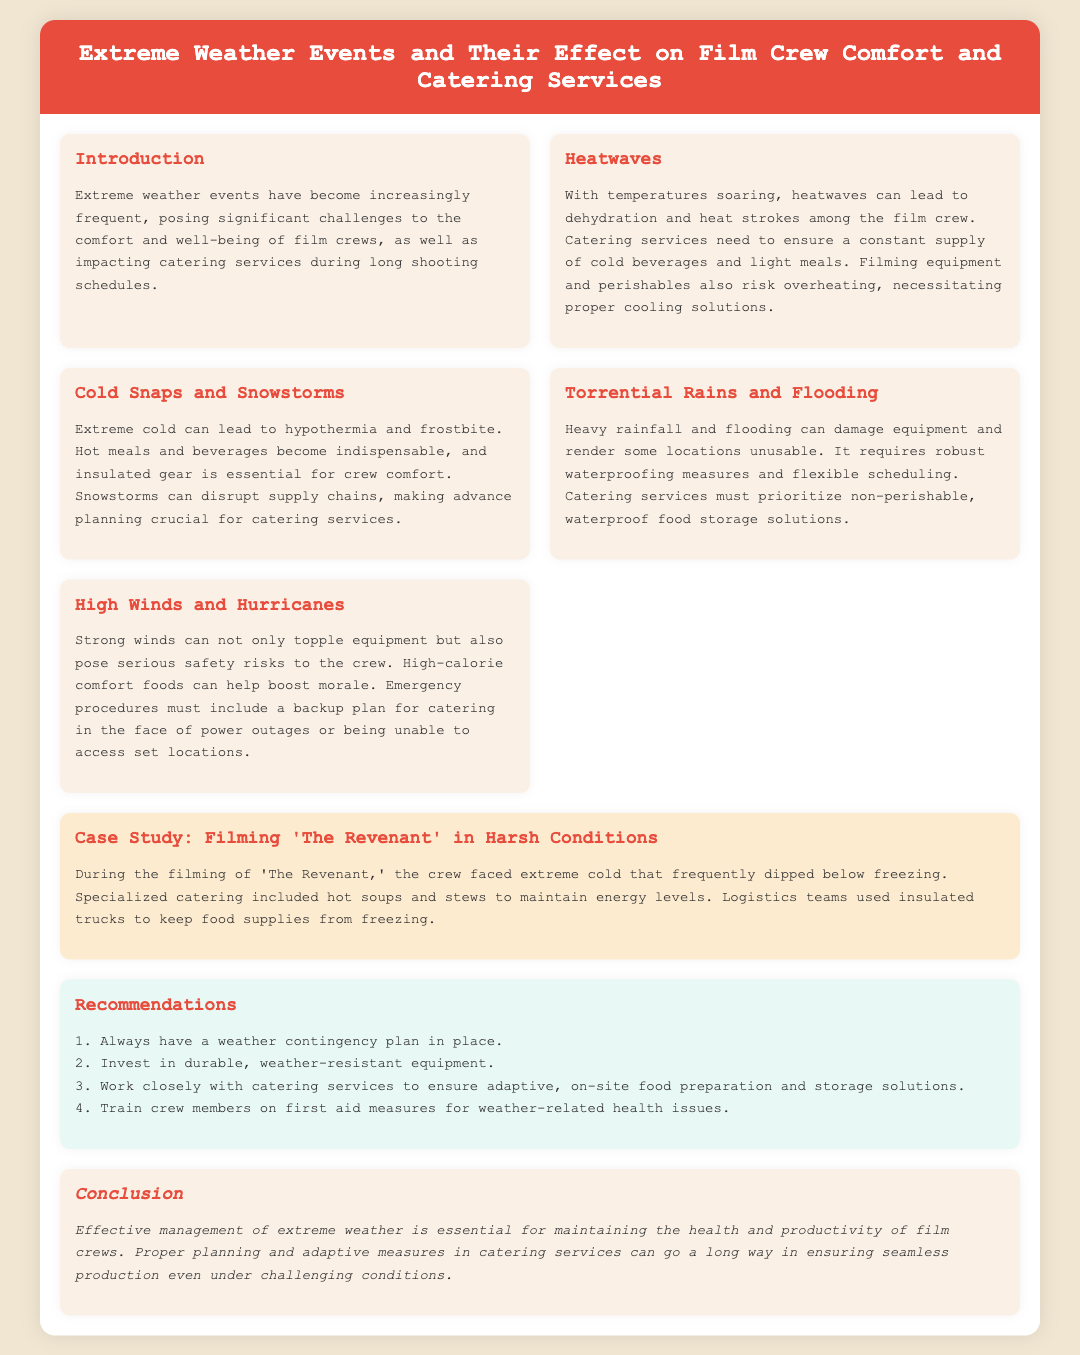What is the title of the document? The title of the document is presented in the header section, which is "Extreme Weather Events and Their Effect on Film Crew Comfort and Catering Services."
Answer: Extreme Weather Events and Their Effect on Film Crew Comfort and Catering Services What are the challenges posed by heatwaves? The challenges posed by heatwaves include dehydration and heat strokes among the film crew.
Answer: Dehydration and heat strokes What is crucial for catering during cold snaps and snowstorms? Catering during cold snaps and snowstorms must ensure a supply of hot meals and beverages.
Answer: Hot meals and beverages What is a key recommendation for handling extreme weather? A key recommendation is to always have a weather contingency plan in place.
Answer: Weather contingency plan What type of food is suggested during high winds? High-calorie comfort foods are suggested to help boost crew morale during high winds.
Answer: High-calorie comfort foods What was the filming condition experienced in 'The Revenant'? During the filming of 'The Revenant,' the crew faced extreme cold that frequently dipped below freezing.
Answer: Extreme cold What is the impact of torrential rains on catering services? Torrential rains require catering services to prioritize non-perishable, waterproof food storage solutions.
Answer: Non-perishable, waterproof food storage solutions What is one essential gear for crew comfort during extreme cold? Insulated gear is essential for crew comfort during extreme cold.
Answer: Insulated gear 